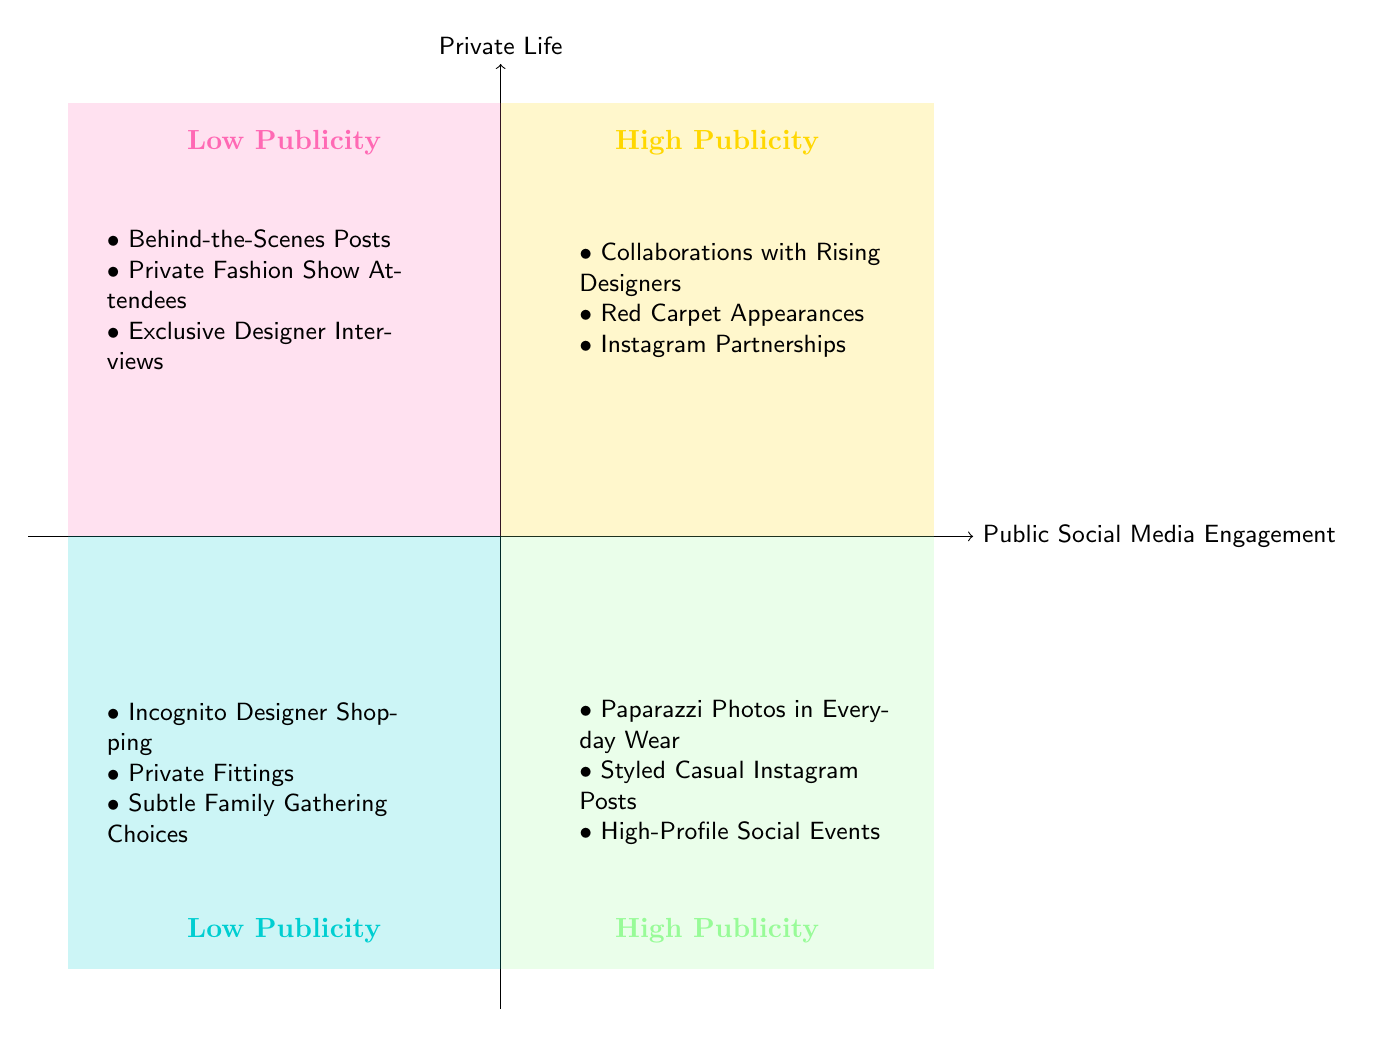What are examples of high publicity actions in the quadrant for Public Social Media Engagement? In the quadrant labeled "High Publicity" under "Public Social Media Engagement," we can see three actions listed: "Collaborations with Rising Designers," "Red Carpet Appearances in Unique Outfits," and "Instagram Partnerships."
Answer: Collaborations with Rising Designers, Red Carpet Appearances in Unique Outfits, Instagram Partnerships How many low publicity examples are listed in the quadrant for Private Life? Under the quadrant labeled "Low Publicity" for "Private Life," there are three actions mentioned: "Shopping Incognito for Designer Pieces," "Private Fittings with Aspiring Designers," and "Subtle Dress Choices for Family Gatherings." Therefore, the total count is three.
Answer: 3 What types of events are included in the High Publicity section of Private Life? In the "High Publicity" section of the "Private Life" quadrant, the actions listed include "Paparazzi Photos in Everyday Wear," "Styled but Casual Posts on Personal Instagram," and "Participation in High-Profile Social Events," indicating these are events that attract significant media attention.
Answer: Paparazzi Photos in Everyday Wear, Styled but Casual Posts on Personal Instagram, Participation in High-Profile Social Events Which quadrant contains more examples, High Publicity for Public Social Media Engagement or Low Publicity for Private Life? The "High Publicity" section of "Public Social Media Engagement" contains three examples, while the "Low Publicity" section of "Private Life" also has three examples. Therefore, both quadrants have an equal number of examples.
Answer: Equal What unique attribute do actions in the "High Publicity" quadrant of Public Social Media Engagement share? The actions listed in the "High Publicity" section of the "Public Social Media Engagement" quadrant all involve aspects of public visibility, connections to the fashion industry, and high-profile collaborations or partnerships, making them notably visible to a broader audience.
Answer: Public visibility and high-profile collaborations Which actions emphasize support for emerging designers? Actions that emphasize support for emerging designers can be found in both quadrants, specifically: "Collaborations with Rising Designers" in Public Engagement's High Publicity and "Private Fittings with Aspiring Designers" in Private Life's Low Publicity, showing both public and private avenues of support.
Answer: Collaborations with Rising Designers, Private Fittings with Aspiring Designers How do "Behind-the-Scenes Posts with Stylist" contrast with "Paparazzi Photos in Everyday Wear"? "Behind-the-Scenes Posts with Stylist" are listed in the Low Publicity section of Public Social Media Engagement, indicating less visibility and a more private context, whereas "Paparazzi Photos in Everyday Wear" are in High Publicity under Private Life, showcasing a more public and casual exposure.
Answer: Behind-the-Scenes Posts are private; Paparazzi Photos are public What is a distinguishing factor of the activities in the Low Publicity category across both quadrants? Activities in the Low Publicity category across both quadrants tend to focus on more personal and less visible aspects of fashion engagement; "Private Fashion Show Attendees" and "Shopping Incognito for Designer Pieces" reflect choice and personal connection rather than broad exposure.
Answer: Personal and less visible aspects of fashion engagement 